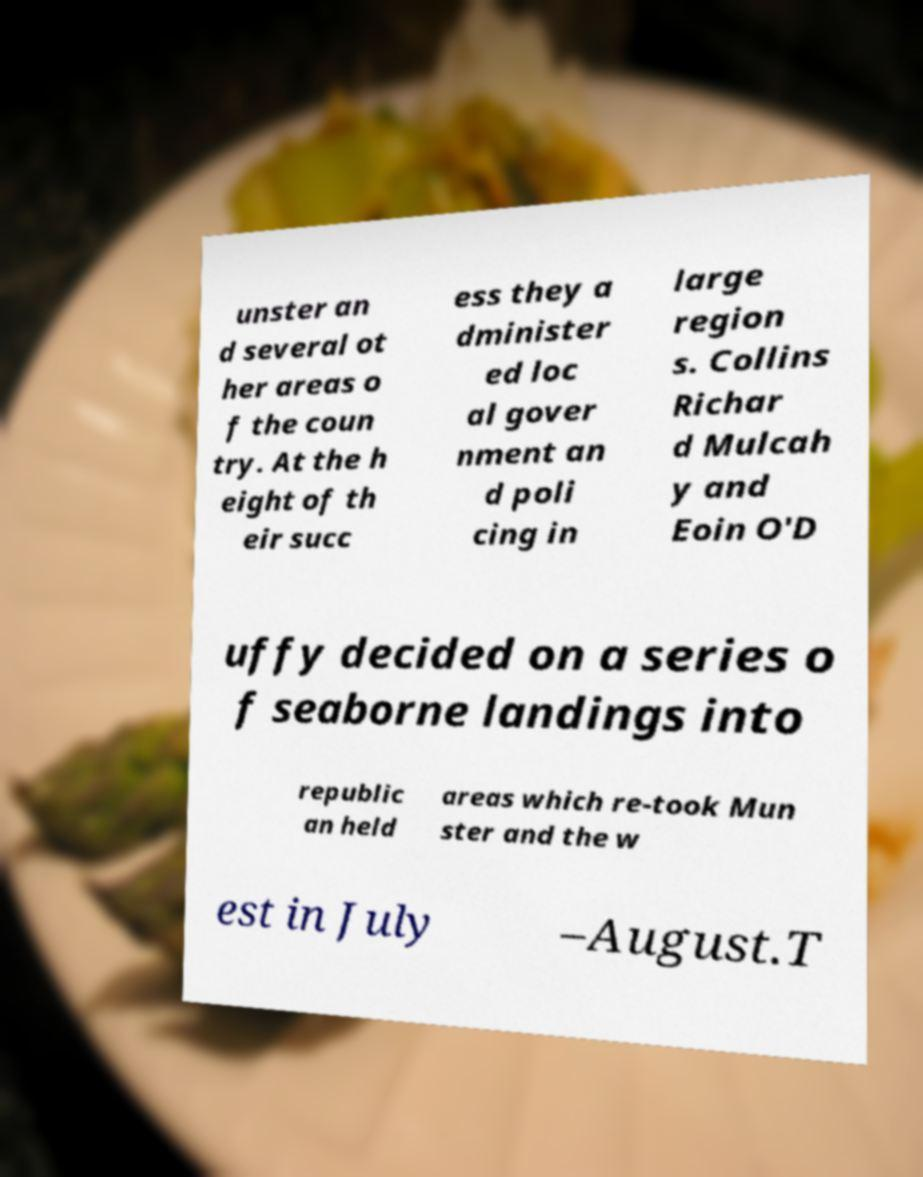Can you read and provide the text displayed in the image?This photo seems to have some interesting text. Can you extract and type it out for me? unster an d several ot her areas o f the coun try. At the h eight of th eir succ ess they a dminister ed loc al gover nment an d poli cing in large region s. Collins Richar d Mulcah y and Eoin O'D uffy decided on a series o f seaborne landings into republic an held areas which re-took Mun ster and the w est in July –August.T 